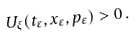Convert formula to latex. <formula><loc_0><loc_0><loc_500><loc_500>U _ { \xi } ( t _ { \varepsilon } , x _ { \varepsilon } , p _ { \varepsilon } ) > 0 \, .</formula> 